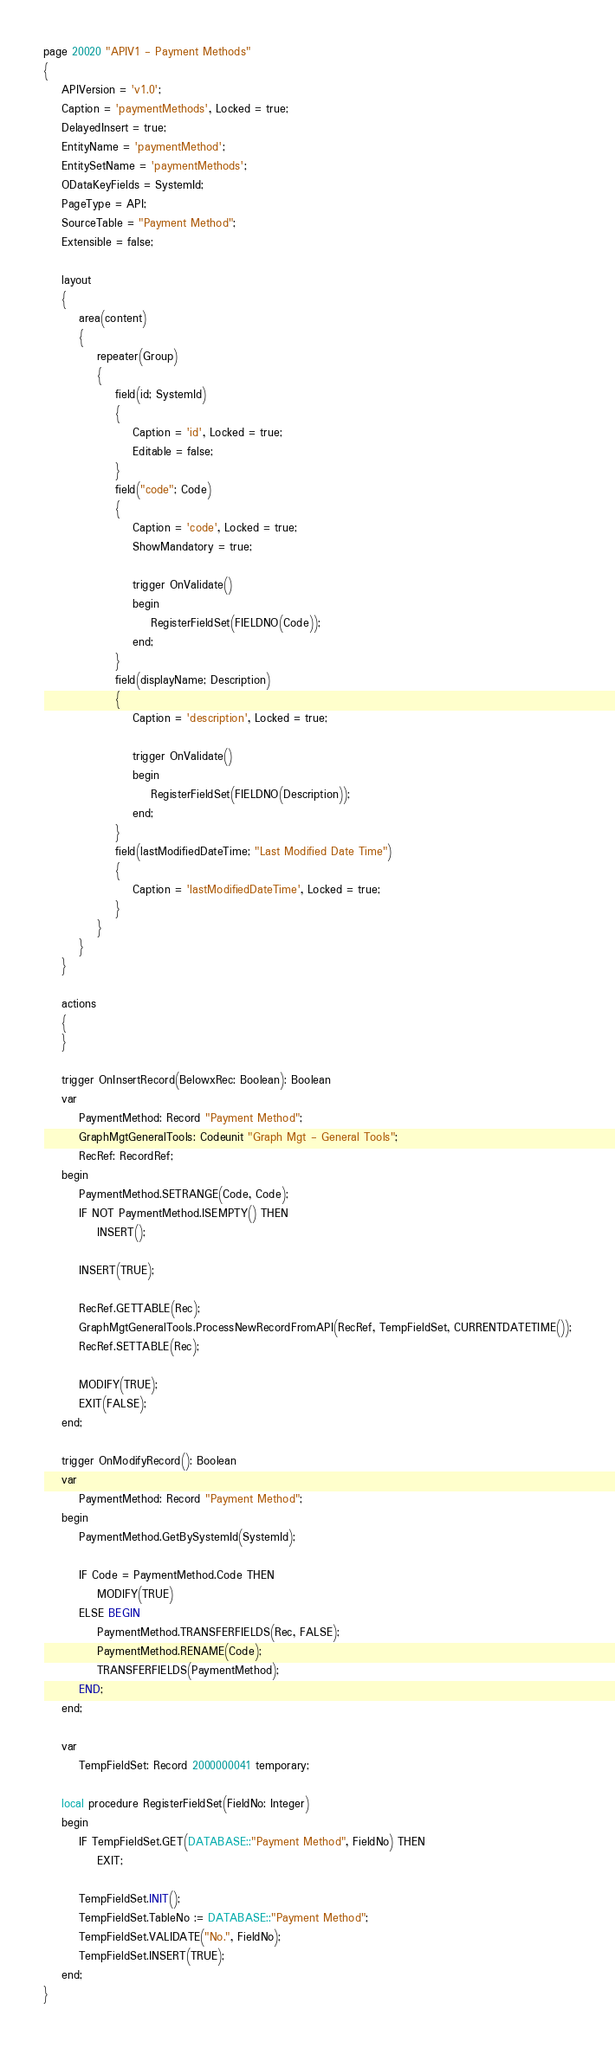<code> <loc_0><loc_0><loc_500><loc_500><_Perl_>page 20020 "APIV1 - Payment Methods"
{
    APIVersion = 'v1.0';
    Caption = 'paymentMethods', Locked = true;
    DelayedInsert = true;
    EntityName = 'paymentMethod';
    EntitySetName = 'paymentMethods';
    ODataKeyFields = SystemId;
    PageType = API;
    SourceTable = "Payment Method";
    Extensible = false;

    layout
    {
        area(content)
        {
            repeater(Group)
            {
                field(id; SystemId)
                {
                    Caption = 'id', Locked = true;
                    Editable = false;
                }
                field("code"; Code)
                {
                    Caption = 'code', Locked = true;
                    ShowMandatory = true;

                    trigger OnValidate()
                    begin
                        RegisterFieldSet(FIELDNO(Code));
                    end;
                }
                field(displayName; Description)
                {
                    Caption = 'description', Locked = true;

                    trigger OnValidate()
                    begin
                        RegisterFieldSet(FIELDNO(Description));
                    end;
                }
                field(lastModifiedDateTime; "Last Modified Date Time")
                {
                    Caption = 'lastModifiedDateTime', Locked = true;
                }
            }
        }
    }

    actions
    {
    }

    trigger OnInsertRecord(BelowxRec: Boolean): Boolean
    var
        PaymentMethod: Record "Payment Method";
        GraphMgtGeneralTools: Codeunit "Graph Mgt - General Tools";
        RecRef: RecordRef;
    begin
        PaymentMethod.SETRANGE(Code, Code);
        IF NOT PaymentMethod.ISEMPTY() THEN
            INSERT();

        INSERT(TRUE);

        RecRef.GETTABLE(Rec);
        GraphMgtGeneralTools.ProcessNewRecordFromAPI(RecRef, TempFieldSet, CURRENTDATETIME());
        RecRef.SETTABLE(Rec);

        MODIFY(TRUE);
        EXIT(FALSE);
    end;

    trigger OnModifyRecord(): Boolean
    var
        PaymentMethod: Record "Payment Method";
    begin
        PaymentMethod.GetBySystemId(SystemId);

        IF Code = PaymentMethod.Code THEN
            MODIFY(TRUE)
        ELSE BEGIN
            PaymentMethod.TRANSFERFIELDS(Rec, FALSE);
            PaymentMethod.RENAME(Code);
            TRANSFERFIELDS(PaymentMethod);
        END;
    end;

    var
        TempFieldSet: Record 2000000041 temporary;

    local procedure RegisterFieldSet(FieldNo: Integer)
    begin
        IF TempFieldSet.GET(DATABASE::"Payment Method", FieldNo) THEN
            EXIT;

        TempFieldSet.INIT();
        TempFieldSet.TableNo := DATABASE::"Payment Method";
        TempFieldSet.VALIDATE("No.", FieldNo);
        TempFieldSet.INSERT(TRUE);
    end;
}






</code> 